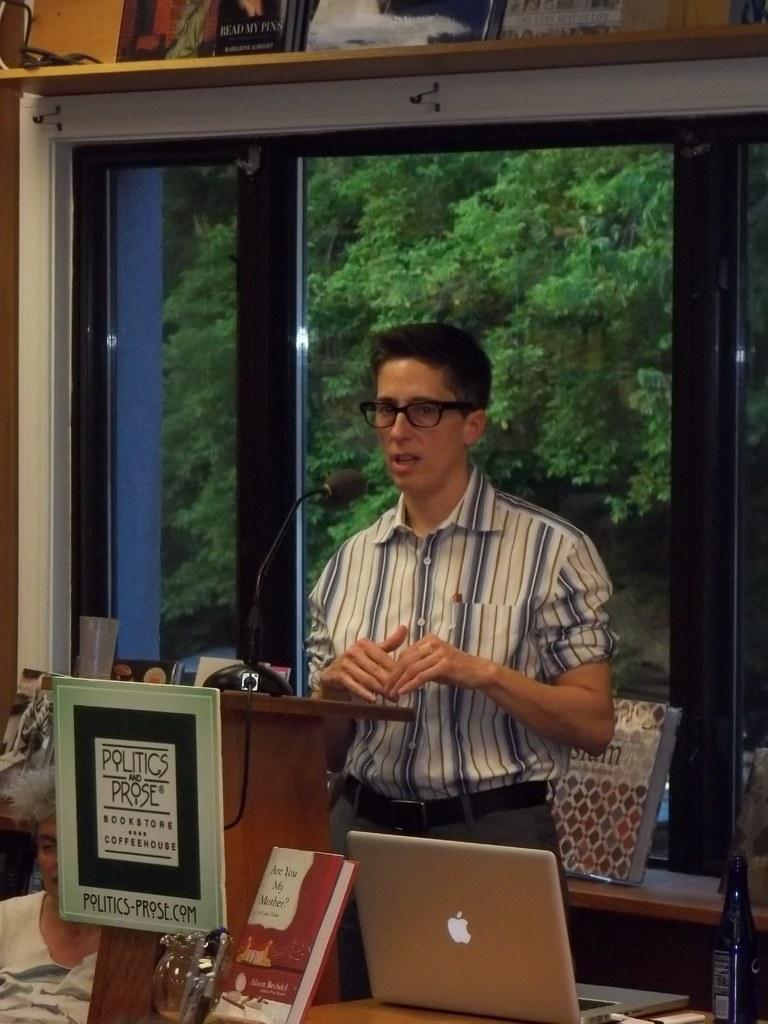In one or two sentences, can you explain what this image depicts? This man is standing wore shirt, spectacles and talking in-front of mic. In-front of this person there is a podium with board. On this table there is a book, bottle and laptop. From this window we can able to see trees. Above the window there are books. A woman is sitting on a chair. 